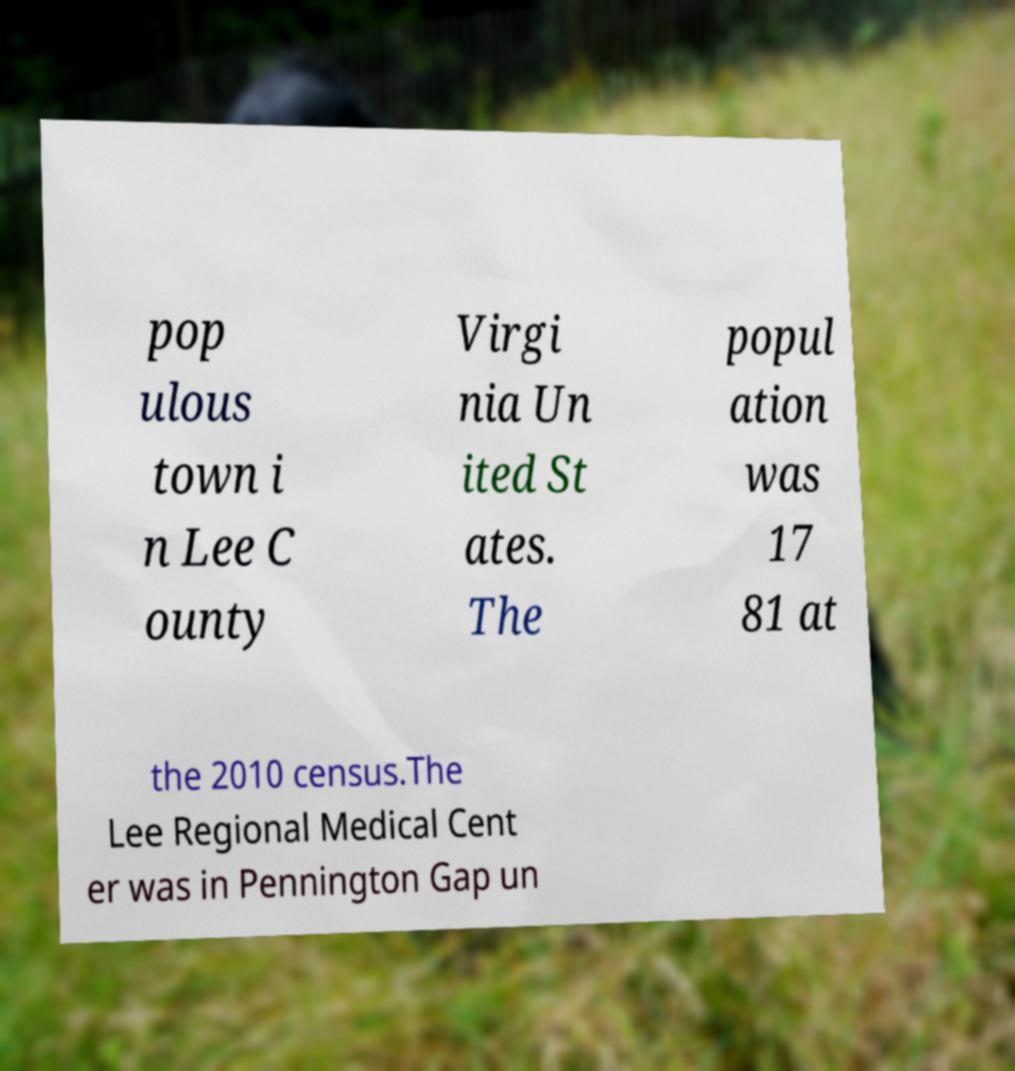Can you read and provide the text displayed in the image?This photo seems to have some interesting text. Can you extract and type it out for me? pop ulous town i n Lee C ounty Virgi nia Un ited St ates. The popul ation was 17 81 at the 2010 census.The Lee Regional Medical Cent er was in Pennington Gap un 